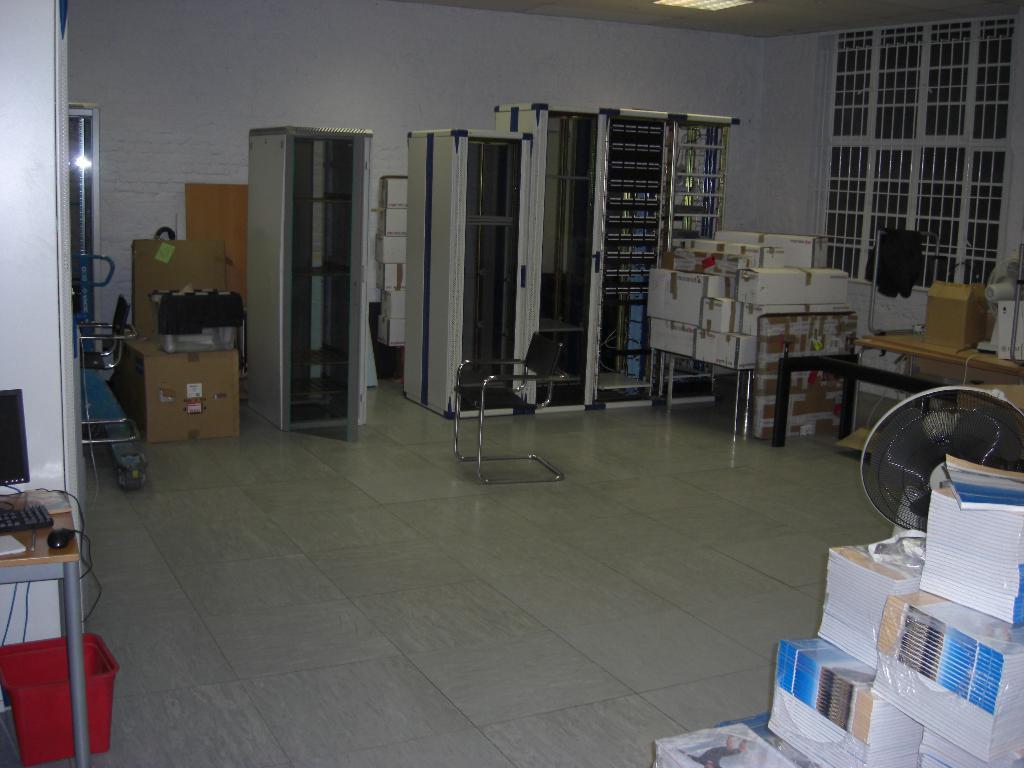In one or two sentences, can you explain what this image depicts? In this picture we can see books and a table fan at the right bottom, in the background there are some cardboard boxes, we can see a chair in the middle, on the left side there is a table, we can see a monitor, a keyboard and a mouse present on the table, there are some racks here, on the right side we can see windows, there is a wall here. 